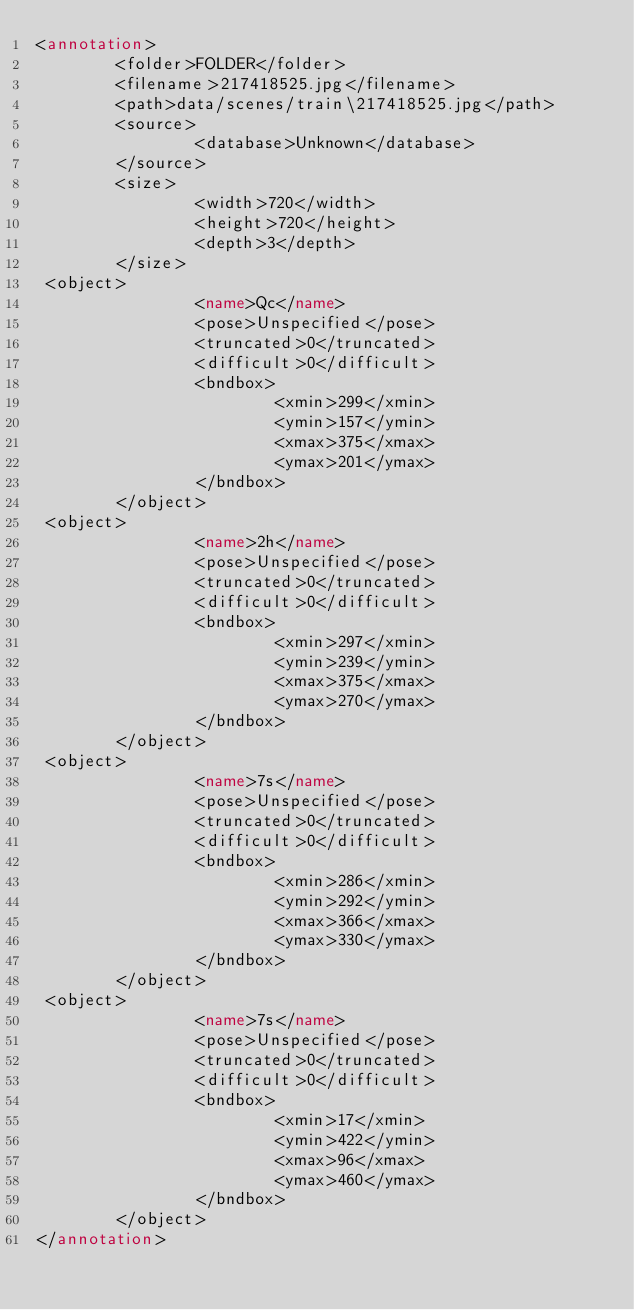<code> <loc_0><loc_0><loc_500><loc_500><_XML_><annotation>
        <folder>FOLDER</folder>
        <filename>217418525.jpg</filename>
        <path>data/scenes/train\217418525.jpg</path>
        <source>
                <database>Unknown</database>
        </source>
        <size>
                <width>720</width>
                <height>720</height>
                <depth>3</depth>
        </size>
 <object>
                <name>Qc</name>
                <pose>Unspecified</pose>
                <truncated>0</truncated>
                <difficult>0</difficult>
                <bndbox>
                        <xmin>299</xmin>
                        <ymin>157</ymin>
                        <xmax>375</xmax>
                        <ymax>201</ymax>
                </bndbox>
        </object>
 <object>
                <name>2h</name>
                <pose>Unspecified</pose>
                <truncated>0</truncated>
                <difficult>0</difficult>
                <bndbox>
                        <xmin>297</xmin>
                        <ymin>239</ymin>
                        <xmax>375</xmax>
                        <ymax>270</ymax>
                </bndbox>
        </object>
 <object>
                <name>7s</name>
                <pose>Unspecified</pose>
                <truncated>0</truncated>
                <difficult>0</difficult>
                <bndbox>
                        <xmin>286</xmin>
                        <ymin>292</ymin>
                        <xmax>366</xmax>
                        <ymax>330</ymax>
                </bndbox>
        </object>
 <object>
                <name>7s</name>
                <pose>Unspecified</pose>
                <truncated>0</truncated>
                <difficult>0</difficult>
                <bndbox>
                        <xmin>17</xmin>
                        <ymin>422</ymin>
                        <xmax>96</xmax>
                        <ymax>460</ymax>
                </bndbox>
        </object>
</annotation>        
</code> 